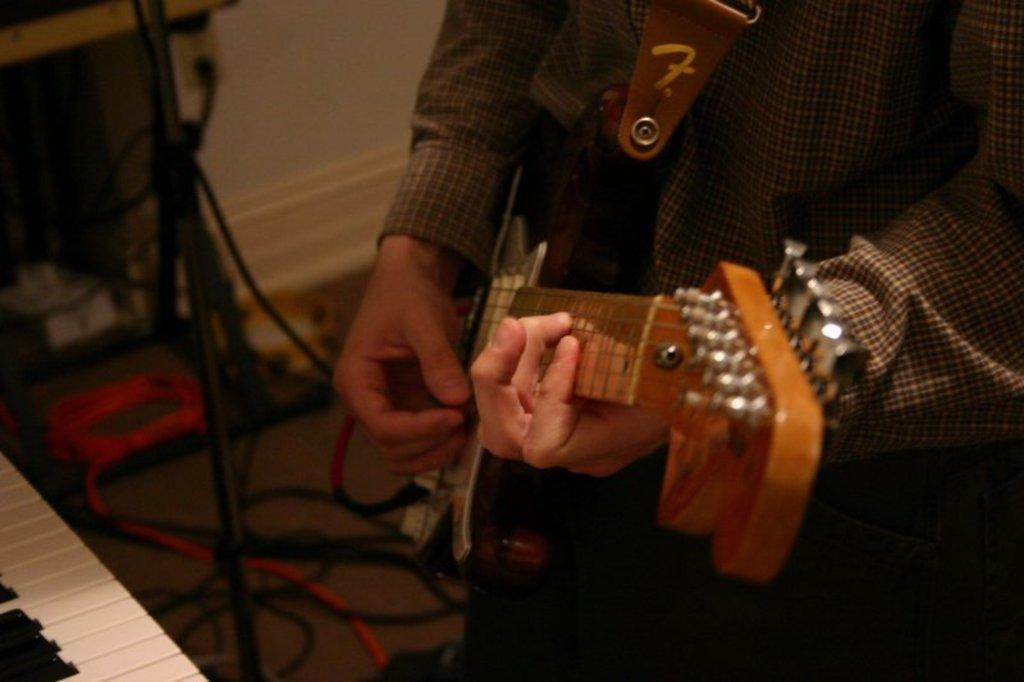What is the person in the image doing? The person in the image is playing a guitar. What musical instrument is in front of the person? There is a piano in front of the person. Can you describe the person's activity in the image? The person is playing a guitar while a piano is in front of them. What type of celery is being used as a guide for the person playing the guitar? There is no celery present in the image, and therefore it cannot be used as a guide for the person playing the guitar. 